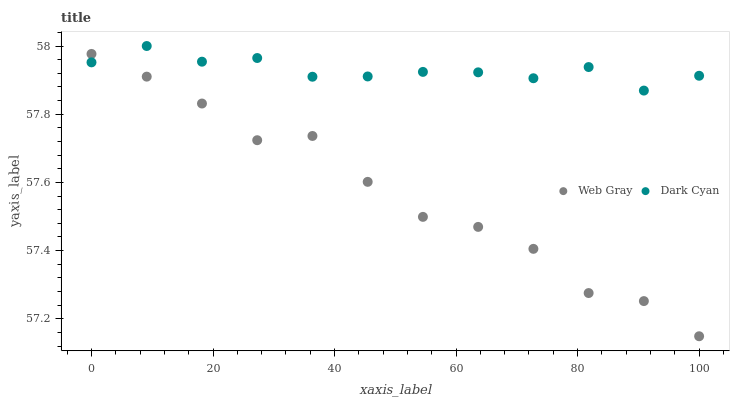Does Web Gray have the minimum area under the curve?
Answer yes or no. Yes. Does Dark Cyan have the maximum area under the curve?
Answer yes or no. Yes. Does Web Gray have the maximum area under the curve?
Answer yes or no. No. Is Dark Cyan the smoothest?
Answer yes or no. Yes. Is Web Gray the roughest?
Answer yes or no. Yes. Is Web Gray the smoothest?
Answer yes or no. No. Does Web Gray have the lowest value?
Answer yes or no. Yes. Does Dark Cyan have the highest value?
Answer yes or no. Yes. Does Web Gray have the highest value?
Answer yes or no. No. Does Dark Cyan intersect Web Gray?
Answer yes or no. Yes. Is Dark Cyan less than Web Gray?
Answer yes or no. No. Is Dark Cyan greater than Web Gray?
Answer yes or no. No. 